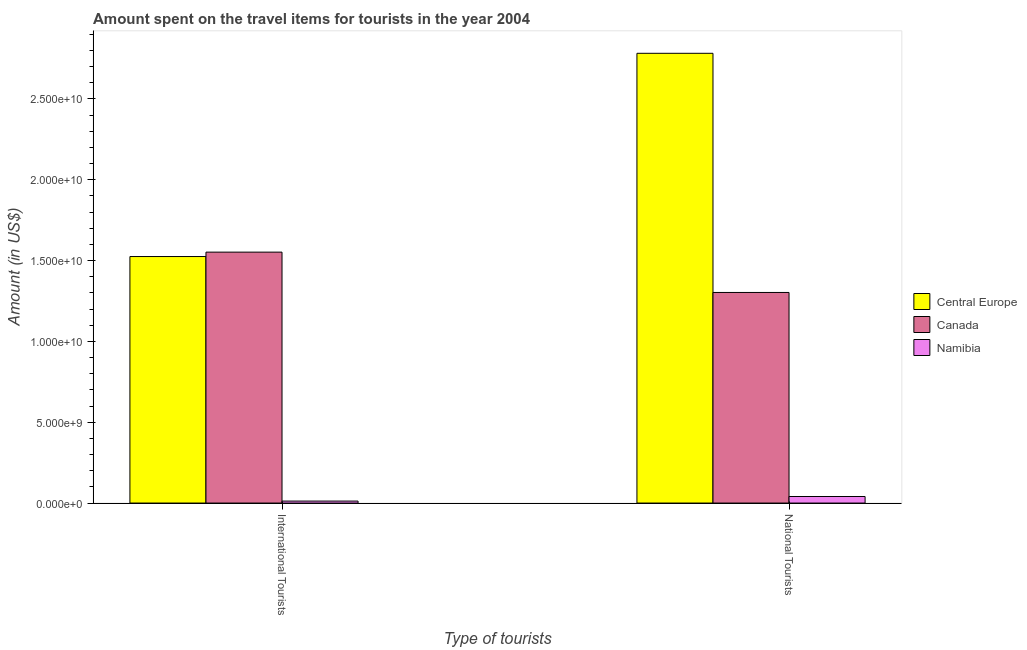How many different coloured bars are there?
Give a very brief answer. 3. How many groups of bars are there?
Your response must be concise. 2. Are the number of bars on each tick of the X-axis equal?
Ensure brevity in your answer.  Yes. What is the label of the 2nd group of bars from the left?
Keep it short and to the point. National Tourists. What is the amount spent on travel items of national tourists in Canada?
Your response must be concise. 1.30e+1. Across all countries, what is the maximum amount spent on travel items of international tourists?
Provide a short and direct response. 1.55e+1. Across all countries, what is the minimum amount spent on travel items of international tourists?
Keep it short and to the point. 1.23e+08. In which country was the amount spent on travel items of national tourists maximum?
Provide a succinct answer. Central Europe. In which country was the amount spent on travel items of national tourists minimum?
Offer a very short reply. Namibia. What is the total amount spent on travel items of international tourists in the graph?
Offer a terse response. 3.09e+1. What is the difference between the amount spent on travel items of national tourists in Namibia and that in Canada?
Make the answer very short. -1.26e+1. What is the difference between the amount spent on travel items of national tourists in Central Europe and the amount spent on travel items of international tourists in Canada?
Provide a short and direct response. 1.23e+1. What is the average amount spent on travel items of national tourists per country?
Provide a short and direct response. 1.38e+1. What is the difference between the amount spent on travel items of international tourists and amount spent on travel items of national tourists in Canada?
Keep it short and to the point. 2.50e+09. What is the ratio of the amount spent on travel items of international tourists in Namibia to that in Canada?
Ensure brevity in your answer.  0.01. Is the amount spent on travel items of national tourists in Namibia less than that in Canada?
Ensure brevity in your answer.  Yes. What does the 2nd bar from the left in International Tourists represents?
Your answer should be very brief. Canada. What does the 2nd bar from the right in National Tourists represents?
Make the answer very short. Canada. How many bars are there?
Your response must be concise. 6. Are all the bars in the graph horizontal?
Your response must be concise. No. What is the difference between two consecutive major ticks on the Y-axis?
Provide a succinct answer. 5.00e+09. Are the values on the major ticks of Y-axis written in scientific E-notation?
Your answer should be compact. Yes. Does the graph contain grids?
Your answer should be very brief. No. Where does the legend appear in the graph?
Offer a terse response. Center right. How many legend labels are there?
Ensure brevity in your answer.  3. How are the legend labels stacked?
Your response must be concise. Vertical. What is the title of the graph?
Your response must be concise. Amount spent on the travel items for tourists in the year 2004. Does "Barbados" appear as one of the legend labels in the graph?
Give a very brief answer. No. What is the label or title of the X-axis?
Provide a short and direct response. Type of tourists. What is the Amount (in US$) in Central Europe in International Tourists?
Your answer should be compact. 1.53e+1. What is the Amount (in US$) in Canada in International Tourists?
Make the answer very short. 1.55e+1. What is the Amount (in US$) of Namibia in International Tourists?
Keep it short and to the point. 1.23e+08. What is the Amount (in US$) in Central Europe in National Tourists?
Your answer should be compact. 2.78e+1. What is the Amount (in US$) in Canada in National Tourists?
Provide a succinct answer. 1.30e+1. What is the Amount (in US$) in Namibia in National Tourists?
Make the answer very short. 4.05e+08. Across all Type of tourists, what is the maximum Amount (in US$) in Central Europe?
Offer a terse response. 2.78e+1. Across all Type of tourists, what is the maximum Amount (in US$) of Canada?
Provide a short and direct response. 1.55e+1. Across all Type of tourists, what is the maximum Amount (in US$) of Namibia?
Make the answer very short. 4.05e+08. Across all Type of tourists, what is the minimum Amount (in US$) in Central Europe?
Your answer should be very brief. 1.53e+1. Across all Type of tourists, what is the minimum Amount (in US$) in Canada?
Offer a terse response. 1.30e+1. Across all Type of tourists, what is the minimum Amount (in US$) in Namibia?
Offer a very short reply. 1.23e+08. What is the total Amount (in US$) in Central Europe in the graph?
Your response must be concise. 4.31e+1. What is the total Amount (in US$) in Canada in the graph?
Your response must be concise. 2.86e+1. What is the total Amount (in US$) in Namibia in the graph?
Give a very brief answer. 5.28e+08. What is the difference between the Amount (in US$) of Central Europe in International Tourists and that in National Tourists?
Give a very brief answer. -1.26e+1. What is the difference between the Amount (in US$) in Canada in International Tourists and that in National Tourists?
Make the answer very short. 2.50e+09. What is the difference between the Amount (in US$) of Namibia in International Tourists and that in National Tourists?
Offer a very short reply. -2.82e+08. What is the difference between the Amount (in US$) of Central Europe in International Tourists and the Amount (in US$) of Canada in National Tourists?
Your answer should be compact. 2.22e+09. What is the difference between the Amount (in US$) of Central Europe in International Tourists and the Amount (in US$) of Namibia in National Tourists?
Provide a short and direct response. 1.48e+1. What is the difference between the Amount (in US$) in Canada in International Tourists and the Amount (in US$) in Namibia in National Tourists?
Your answer should be very brief. 1.51e+1. What is the average Amount (in US$) in Central Europe per Type of tourists?
Give a very brief answer. 2.15e+1. What is the average Amount (in US$) of Canada per Type of tourists?
Make the answer very short. 1.43e+1. What is the average Amount (in US$) in Namibia per Type of tourists?
Your response must be concise. 2.64e+08. What is the difference between the Amount (in US$) in Central Europe and Amount (in US$) in Canada in International Tourists?
Offer a terse response. -2.72e+08. What is the difference between the Amount (in US$) of Central Europe and Amount (in US$) of Namibia in International Tourists?
Keep it short and to the point. 1.51e+1. What is the difference between the Amount (in US$) of Canada and Amount (in US$) of Namibia in International Tourists?
Keep it short and to the point. 1.54e+1. What is the difference between the Amount (in US$) in Central Europe and Amount (in US$) in Canada in National Tourists?
Offer a very short reply. 1.48e+1. What is the difference between the Amount (in US$) of Central Europe and Amount (in US$) of Namibia in National Tourists?
Ensure brevity in your answer.  2.74e+1. What is the difference between the Amount (in US$) in Canada and Amount (in US$) in Namibia in National Tourists?
Give a very brief answer. 1.26e+1. What is the ratio of the Amount (in US$) of Central Europe in International Tourists to that in National Tourists?
Offer a very short reply. 0.55. What is the ratio of the Amount (in US$) of Canada in International Tourists to that in National Tourists?
Provide a short and direct response. 1.19. What is the ratio of the Amount (in US$) in Namibia in International Tourists to that in National Tourists?
Keep it short and to the point. 0.3. What is the difference between the highest and the second highest Amount (in US$) in Central Europe?
Your response must be concise. 1.26e+1. What is the difference between the highest and the second highest Amount (in US$) in Canada?
Give a very brief answer. 2.50e+09. What is the difference between the highest and the second highest Amount (in US$) of Namibia?
Ensure brevity in your answer.  2.82e+08. What is the difference between the highest and the lowest Amount (in US$) of Central Europe?
Keep it short and to the point. 1.26e+1. What is the difference between the highest and the lowest Amount (in US$) of Canada?
Provide a succinct answer. 2.50e+09. What is the difference between the highest and the lowest Amount (in US$) of Namibia?
Keep it short and to the point. 2.82e+08. 